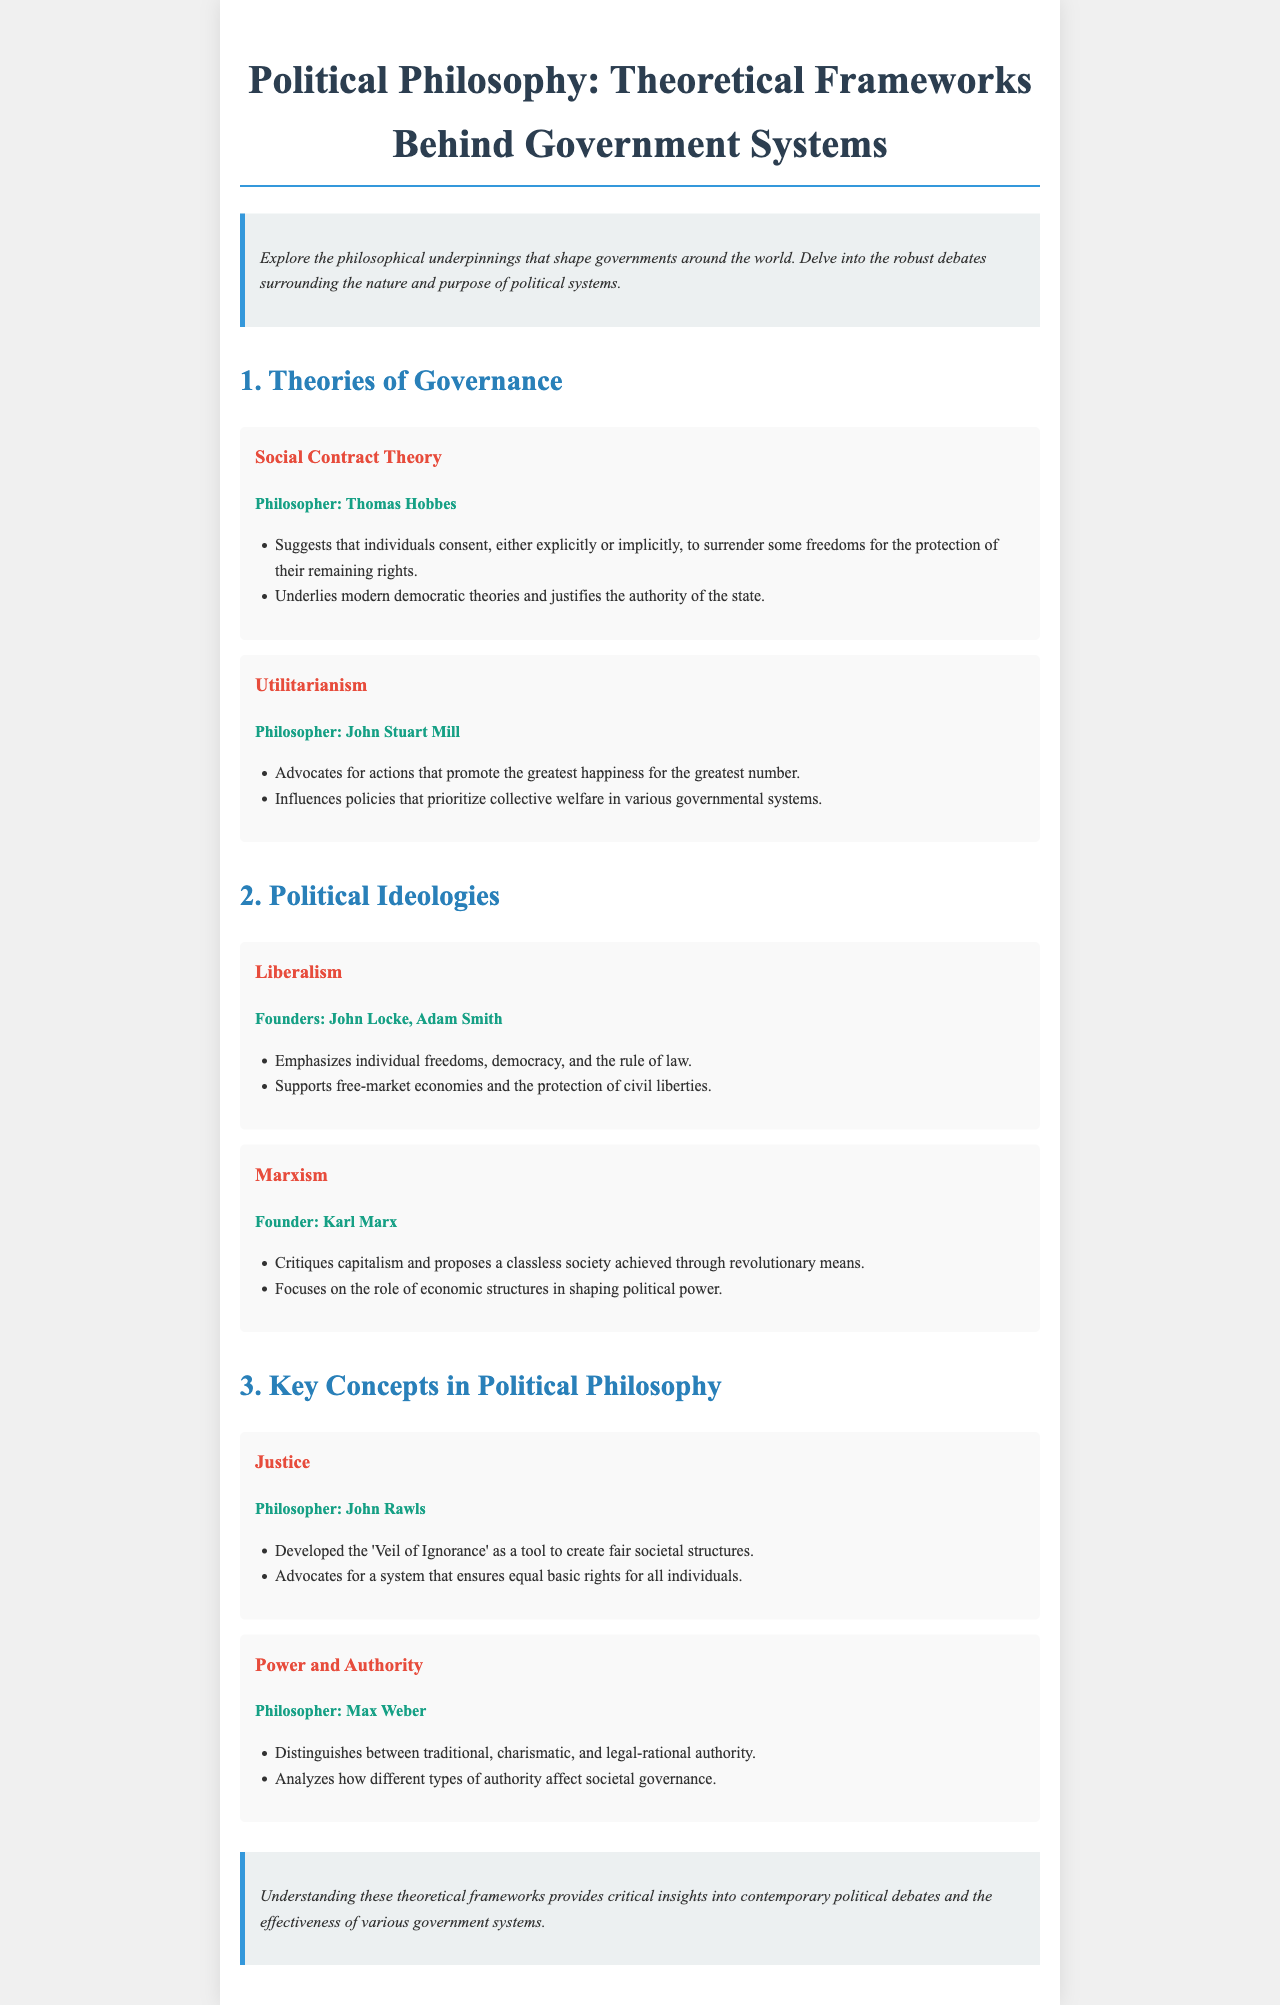What is the title of the document? The title of the document is stated at the top of the brochure.
Answer: Political Philosophy: Theoretical Frameworks Behind Government Systems Who is the philosopher associated with Social Contract Theory? The document explicitly mentions the philosopher connected to this theory.
Answer: Thomas Hobbes What does Utilitarianism advocate for? The document summarizes the main principle of Utilitarianism in a concise manner.
Answer: Greatest happiness for the greatest number Which political ideology emphasizes individual freedoms? The document describes a political ideology that highlights this focus.
Answer: Liberalism What key concept is associated with John Rawls? The document identifies a key concept linked with this philosopher.
Answer: Justice How many types of authority does Max Weber distinguish? The document outlines the different authority types discussed by Max Weber.
Answer: Three What philosophical tool does John Rawls develop? The document provides specific information about a tool that aims to create fairness.
Answer: Veil of Ignorance What is the main critique of Marxism according to the document? The document mentions the primary focus of the critique offered by Marxism.
Answer: Capitalism Who are the founders of Liberalism? The document specifies individuals important to the development of this ideology.
Answer: John Locke, Adam Smith 